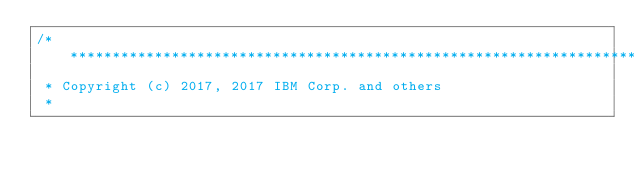<code> <loc_0><loc_0><loc_500><loc_500><_C++_>/*******************************************************************************
 * Copyright (c) 2017, 2017 IBM Corp. and others
 *</code> 